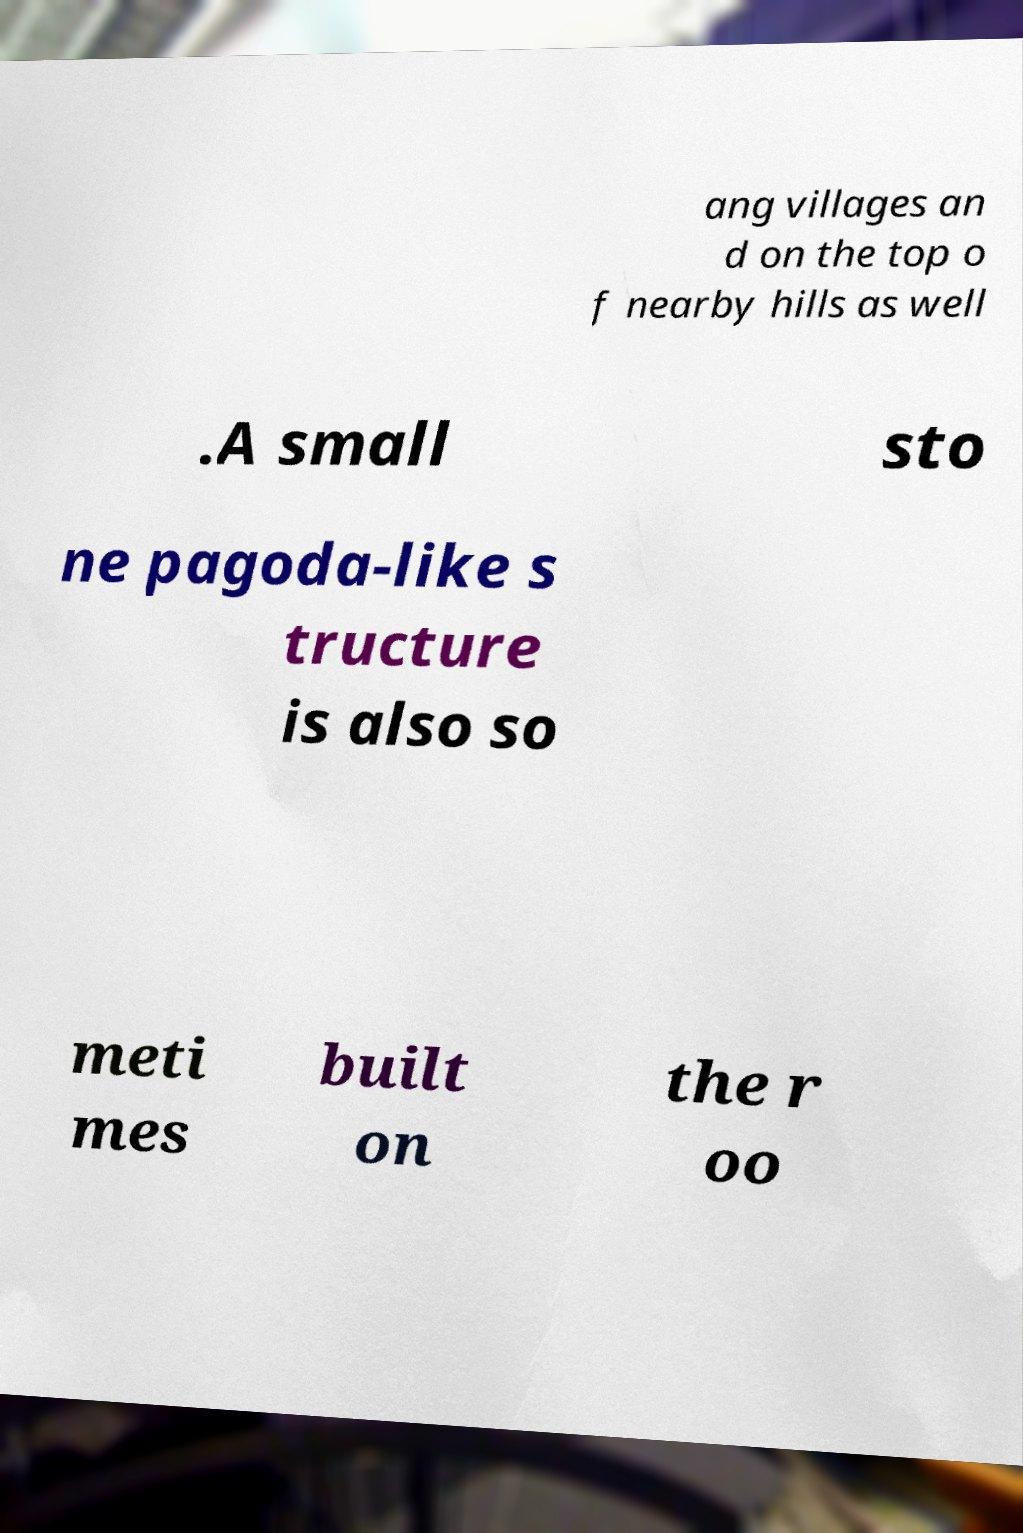Can you read and provide the text displayed in the image?This photo seems to have some interesting text. Can you extract and type it out for me? ang villages an d on the top o f nearby hills as well .A small sto ne pagoda-like s tructure is also so meti mes built on the r oo 